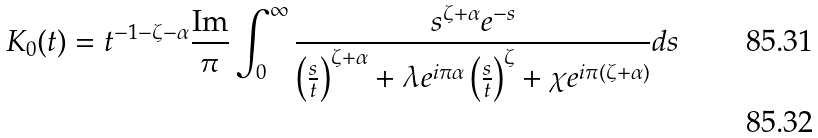<formula> <loc_0><loc_0><loc_500><loc_500>& K _ { 0 } ( t ) = t ^ { - 1 - \zeta - \alpha } \frac { \text {Im} } { \pi } \int _ { 0 } ^ { \infty } \frac { s ^ { \zeta + \alpha } e ^ { - s } } { \left ( \frac { s } { t } \right ) ^ { \zeta + \alpha } + \lambda e ^ { i \pi \alpha } \left ( \frac { s } { t } \right ) ^ { \zeta } + \chi e ^ { i \pi ( \zeta + \alpha ) } } d s \\</formula> 